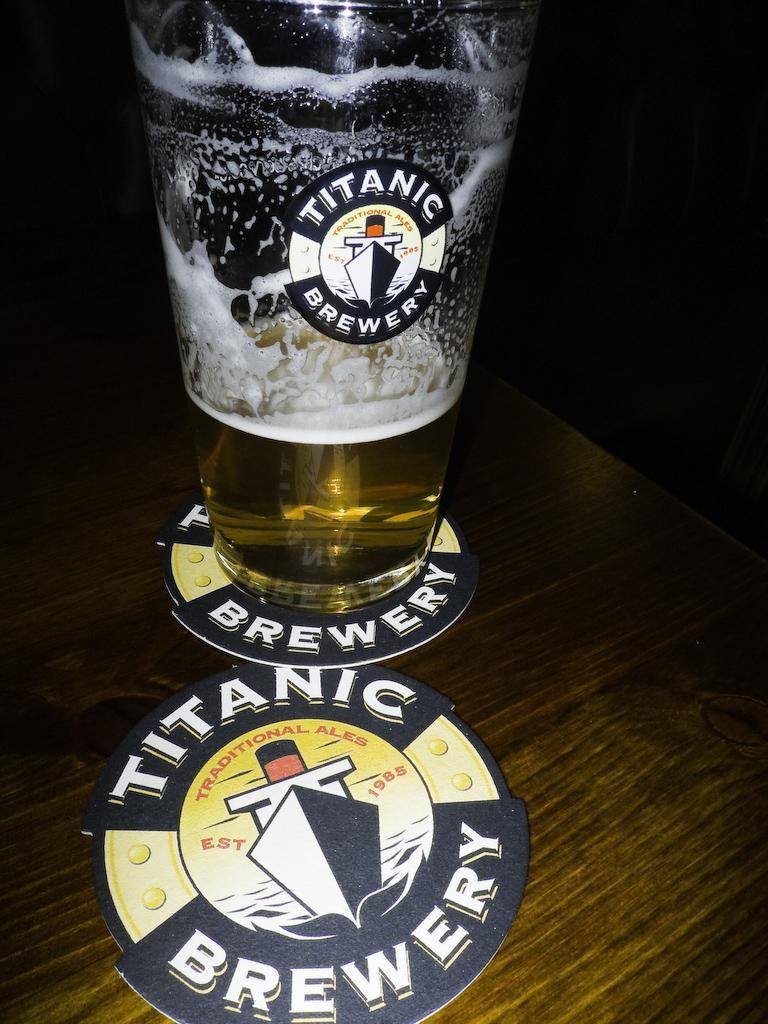Provide a one-sentence caption for the provided image. A glass of ale sits on top of a Titanic Brewery coaster. 